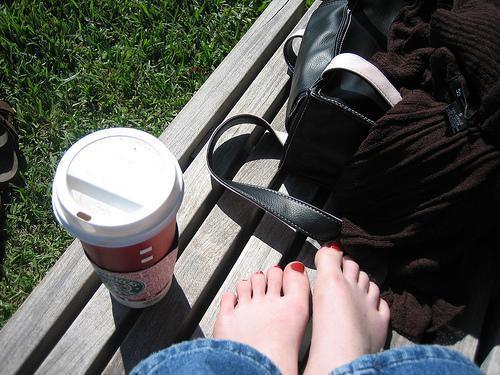How many coffee cups are there?
Give a very brief answer. 1. 